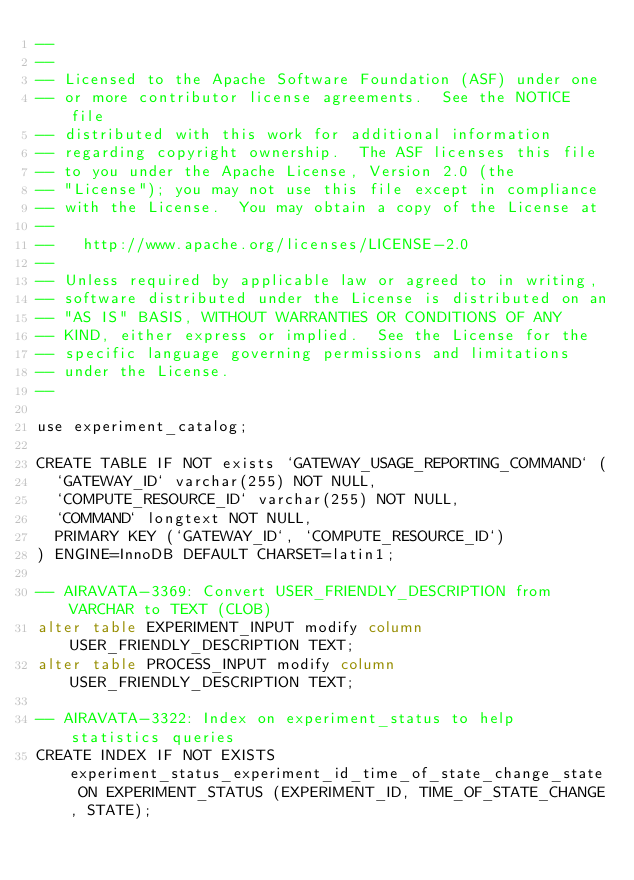Convert code to text. <code><loc_0><loc_0><loc_500><loc_500><_SQL_>--
--
-- Licensed to the Apache Software Foundation (ASF) under one
-- or more contributor license agreements.  See the NOTICE file
-- distributed with this work for additional information
-- regarding copyright ownership.  The ASF licenses this file
-- to you under the Apache License, Version 2.0 (the
-- "License"); you may not use this file except in compliance
-- with the License.  You may obtain a copy of the License at
--
--   http://www.apache.org/licenses/LICENSE-2.0
--
-- Unless required by applicable law or agreed to in writing,
-- software distributed under the License is distributed on an
-- "AS IS" BASIS, WITHOUT WARRANTIES OR CONDITIONS OF ANY
-- KIND, either express or implied.  See the License for the
-- specific language governing permissions and limitations
-- under the License.
--

use experiment_catalog;

CREATE TABLE IF NOT exists `GATEWAY_USAGE_REPORTING_COMMAND` (
  `GATEWAY_ID` varchar(255) NOT NULL,
  `COMPUTE_RESOURCE_ID` varchar(255) NOT NULL,
  `COMMAND` longtext NOT NULL,
  PRIMARY KEY (`GATEWAY_ID`, `COMPUTE_RESOURCE_ID`)
) ENGINE=InnoDB DEFAULT CHARSET=latin1;

-- AIRAVATA-3369: Convert USER_FRIENDLY_DESCRIPTION from VARCHAR to TEXT (CLOB)
alter table EXPERIMENT_INPUT modify column USER_FRIENDLY_DESCRIPTION TEXT;
alter table PROCESS_INPUT modify column USER_FRIENDLY_DESCRIPTION TEXT;

-- AIRAVATA-3322: Index on experiment_status to help statistics queries
CREATE INDEX IF NOT EXISTS experiment_status_experiment_id_time_of_state_change_state ON EXPERIMENT_STATUS (EXPERIMENT_ID, TIME_OF_STATE_CHANGE, STATE);
</code> 